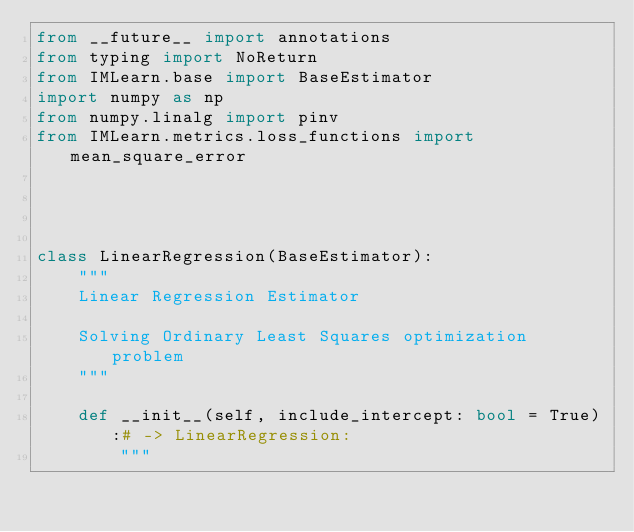<code> <loc_0><loc_0><loc_500><loc_500><_Python_>from __future__ import annotations
from typing import NoReturn
from IMLearn.base import BaseEstimator
import numpy as np
from numpy.linalg import pinv
from IMLearn.metrics.loss_functions import mean_square_error




class LinearRegression(BaseEstimator):
    """
    Linear Regression Estimator

    Solving Ordinary Least Squares optimization problem
    """

    def __init__(self, include_intercept: bool = True):# -> LinearRegression:
        """</code> 